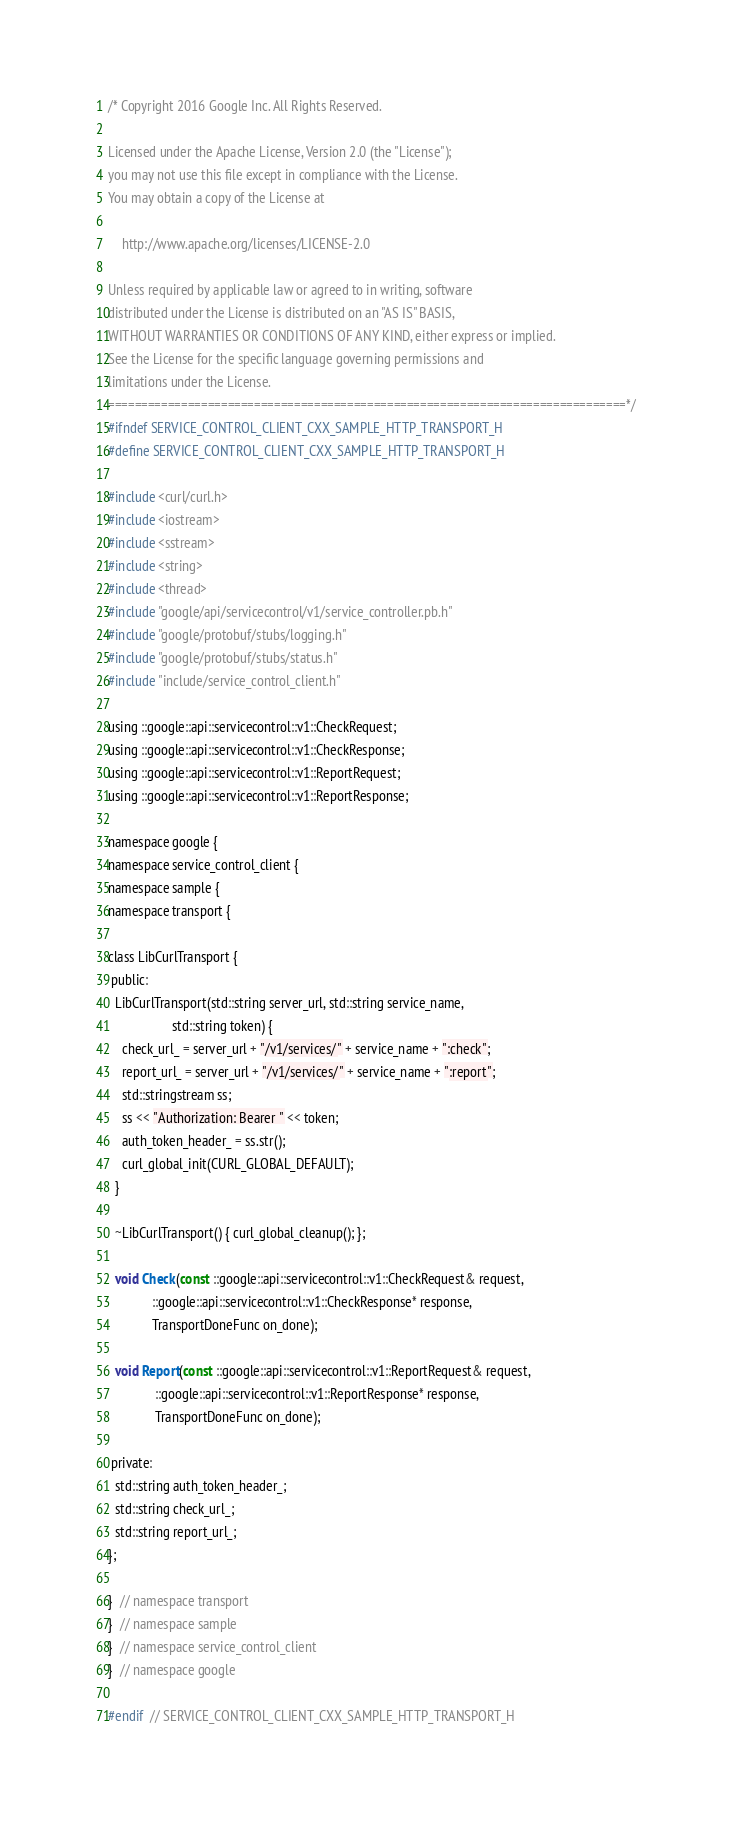<code> <loc_0><loc_0><loc_500><loc_500><_C_>/* Copyright 2016 Google Inc. All Rights Reserved.

Licensed under the Apache License, Version 2.0 (the "License");
you may not use this file except in compliance with the License.
You may obtain a copy of the License at

    http://www.apache.org/licenses/LICENSE-2.0

Unless required by applicable law or agreed to in writing, software
distributed under the License is distributed on an "AS IS" BASIS,
WITHOUT WARRANTIES OR CONDITIONS OF ANY KIND, either express or implied.
See the License for the specific language governing permissions and
limitations under the License.
==============================================================================*/
#ifndef SERVICE_CONTROL_CLIENT_CXX_SAMPLE_HTTP_TRANSPORT_H
#define SERVICE_CONTROL_CLIENT_CXX_SAMPLE_HTTP_TRANSPORT_H

#include <curl/curl.h>
#include <iostream>
#include <sstream>
#include <string>
#include <thread>
#include "google/api/servicecontrol/v1/service_controller.pb.h"
#include "google/protobuf/stubs/logging.h"
#include "google/protobuf/stubs/status.h"
#include "include/service_control_client.h"

using ::google::api::servicecontrol::v1::CheckRequest;
using ::google::api::servicecontrol::v1::CheckResponse;
using ::google::api::servicecontrol::v1::ReportRequest;
using ::google::api::servicecontrol::v1::ReportResponse;

namespace google {
namespace service_control_client {
namespace sample {
namespace transport {

class LibCurlTransport {
 public:
  LibCurlTransport(std::string server_url, std::string service_name,
                   std::string token) {
    check_url_ = server_url + "/v1/services/" + service_name + ":check";
    report_url_ = server_url + "/v1/services/" + service_name + ":report";
    std::stringstream ss;
    ss << "Authorization: Bearer " << token;
    auth_token_header_ = ss.str();
    curl_global_init(CURL_GLOBAL_DEFAULT);
  }

  ~LibCurlTransport() { curl_global_cleanup(); };

  void Check(const ::google::api::servicecontrol::v1::CheckRequest& request,
             ::google::api::servicecontrol::v1::CheckResponse* response,
             TransportDoneFunc on_done);

  void Report(const ::google::api::servicecontrol::v1::ReportRequest& request,
              ::google::api::servicecontrol::v1::ReportResponse* response,
              TransportDoneFunc on_done);

 private:
  std::string auth_token_header_;
  std::string check_url_;
  std::string report_url_;
};

}  // namespace transport
}  // namespace sample
}  // namespace service_control_client
}  // namespace google

#endif  // SERVICE_CONTROL_CLIENT_CXX_SAMPLE_HTTP_TRANSPORT_H
</code> 